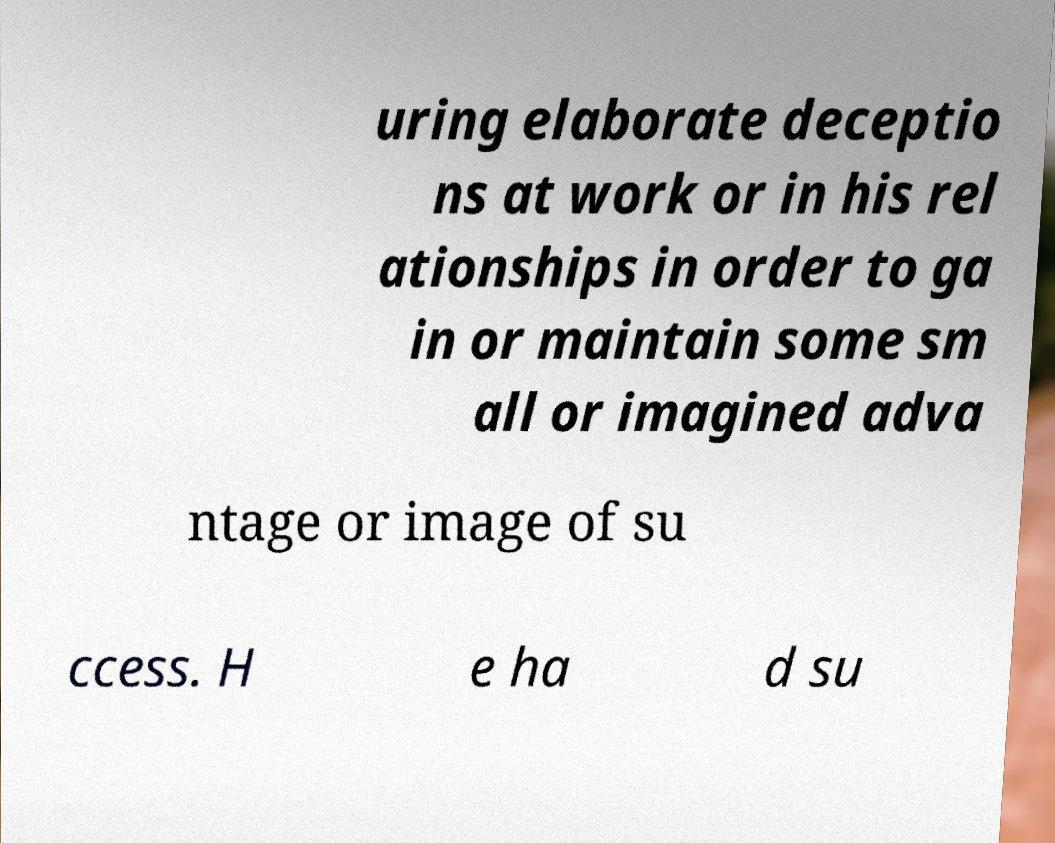Can you accurately transcribe the text from the provided image for me? uring elaborate deceptio ns at work or in his rel ationships in order to ga in or maintain some sm all or imagined adva ntage or image of su ccess. H e ha d su 